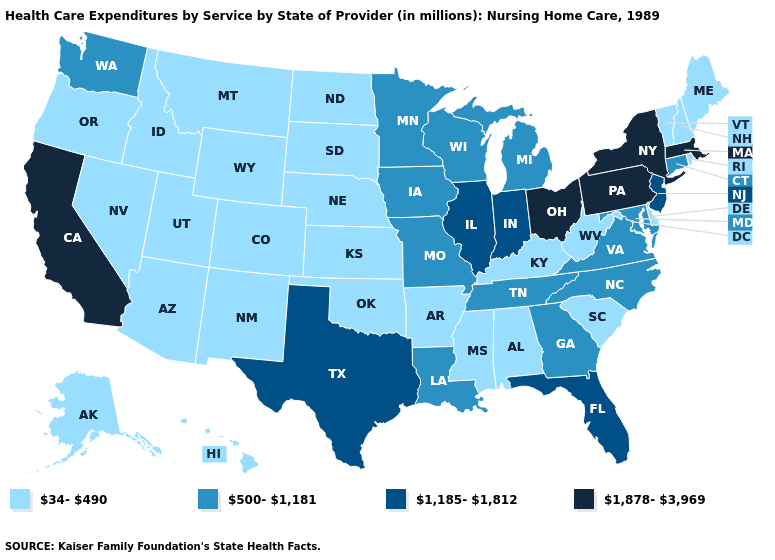Does the map have missing data?
Answer briefly. No. Does Arizona have the same value as New York?
Short answer required. No. Name the states that have a value in the range 1,878-3,969?
Concise answer only. California, Massachusetts, New York, Ohio, Pennsylvania. Does Connecticut have the highest value in the Northeast?
Be succinct. No. Name the states that have a value in the range 1,878-3,969?
Give a very brief answer. California, Massachusetts, New York, Ohio, Pennsylvania. Name the states that have a value in the range 1,878-3,969?
Short answer required. California, Massachusetts, New York, Ohio, Pennsylvania. Among the states that border Nebraska , which have the highest value?
Keep it brief. Iowa, Missouri. Does Rhode Island have a higher value than Indiana?
Quick response, please. No. What is the value of New York?
Quick response, please. 1,878-3,969. Among the states that border New Hampshire , does Vermont have the lowest value?
Quick response, please. Yes. What is the lowest value in the USA?
Answer briefly. 34-490. What is the value of Vermont?
Short answer required. 34-490. Among the states that border Nevada , does California have the lowest value?
Answer briefly. No. Among the states that border Indiana , does Michigan have the highest value?
Give a very brief answer. No. 